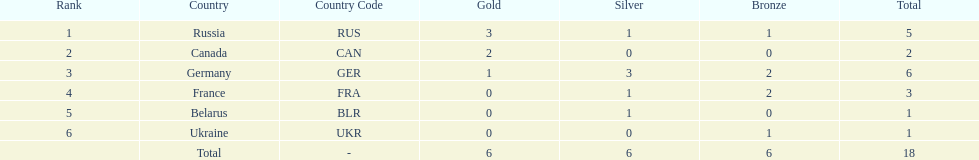What country only received gold medals in the 1994 winter olympics biathlon? Canada (CAN). 